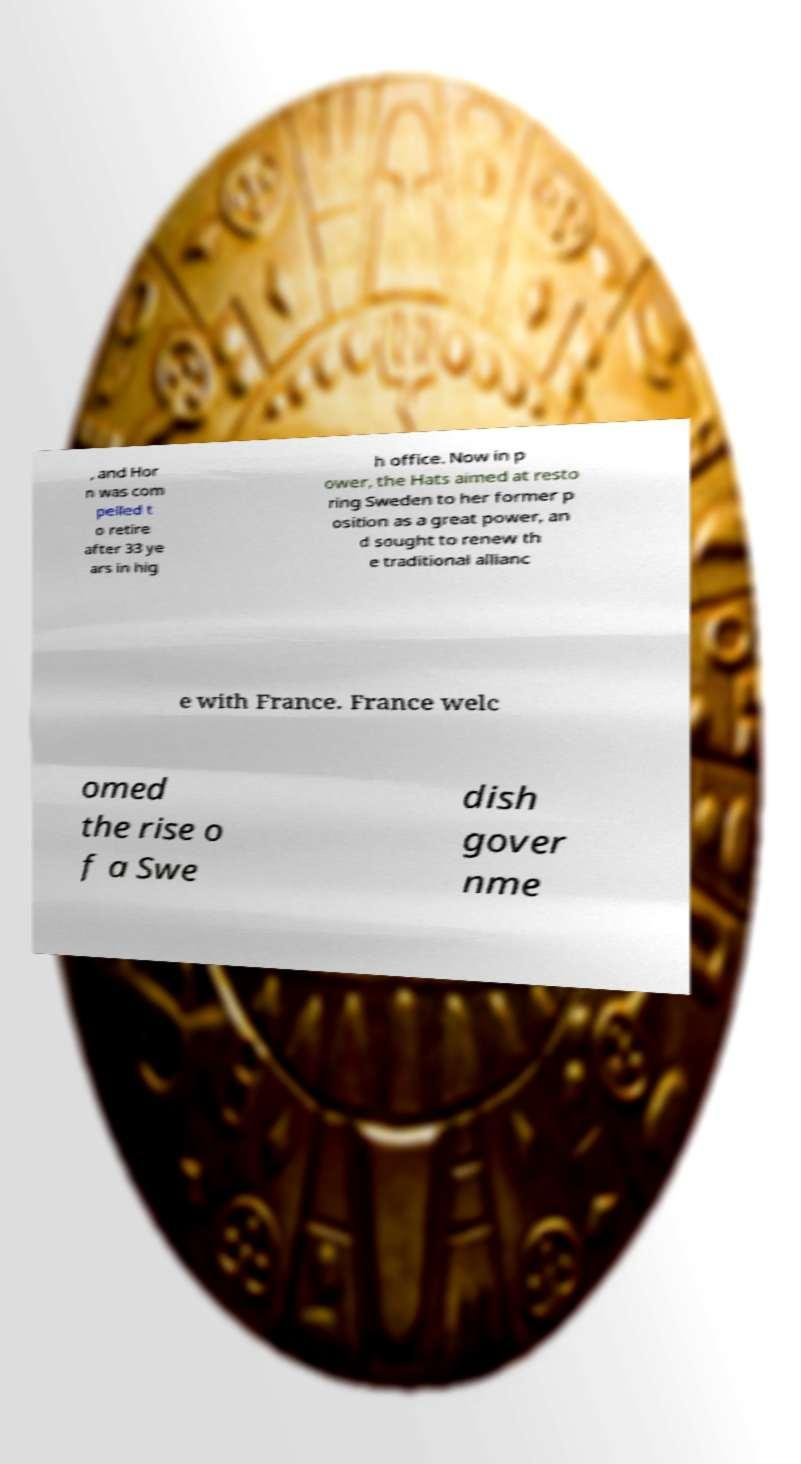Please identify and transcribe the text found in this image. , and Hor n was com pelled t o retire after 33 ye ars in hig h office. Now in p ower, the Hats aimed at resto ring Sweden to her former p osition as a great power, an d sought to renew th e traditional allianc e with France. France welc omed the rise o f a Swe dish gover nme 